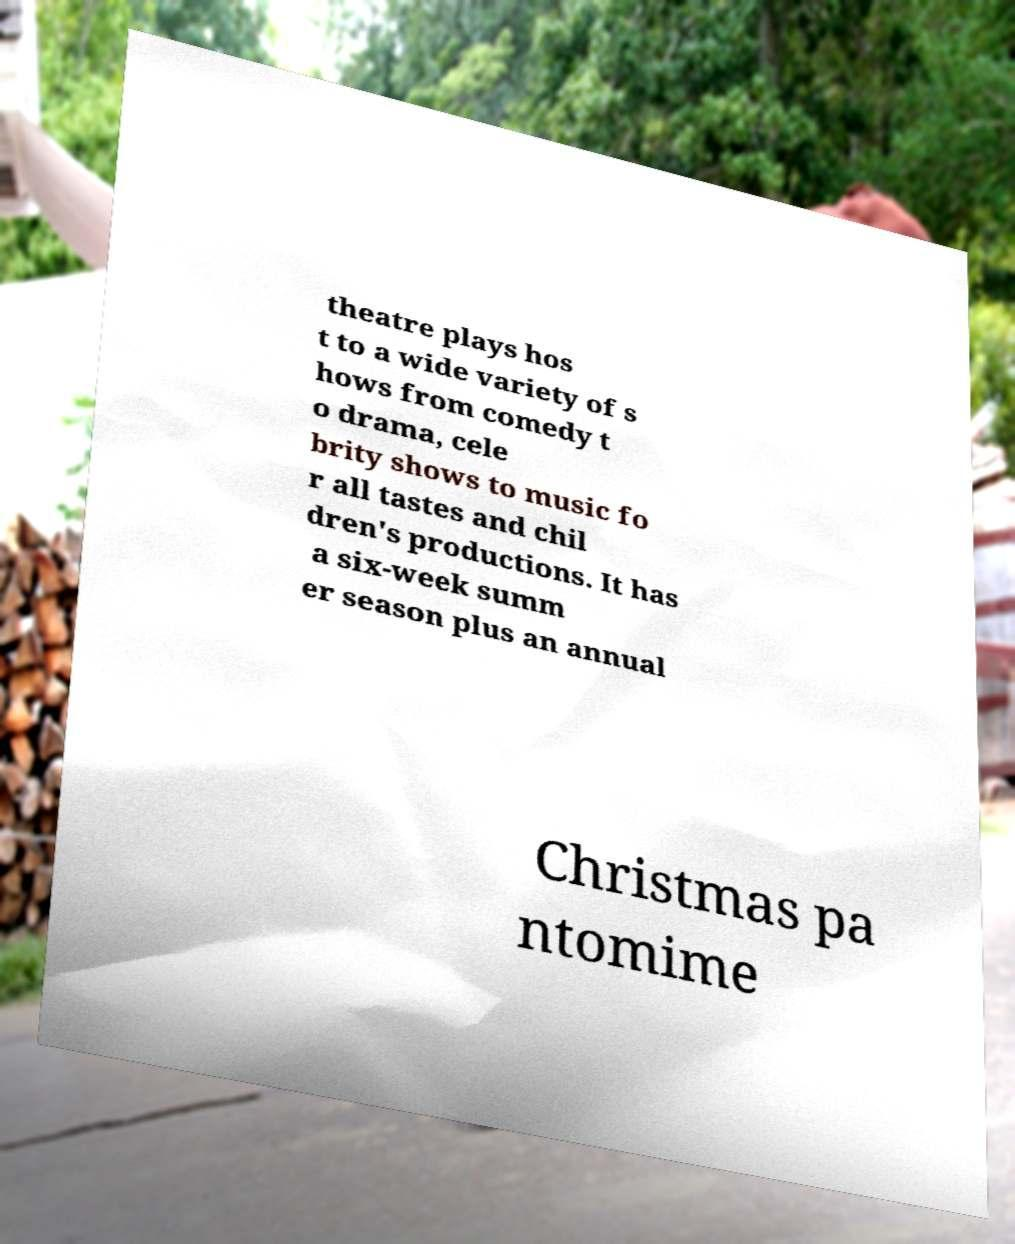Could you assist in decoding the text presented in this image and type it out clearly? theatre plays hos t to a wide variety of s hows from comedy t o drama, cele brity shows to music fo r all tastes and chil dren's productions. It has a six-week summ er season plus an annual Christmas pa ntomime 